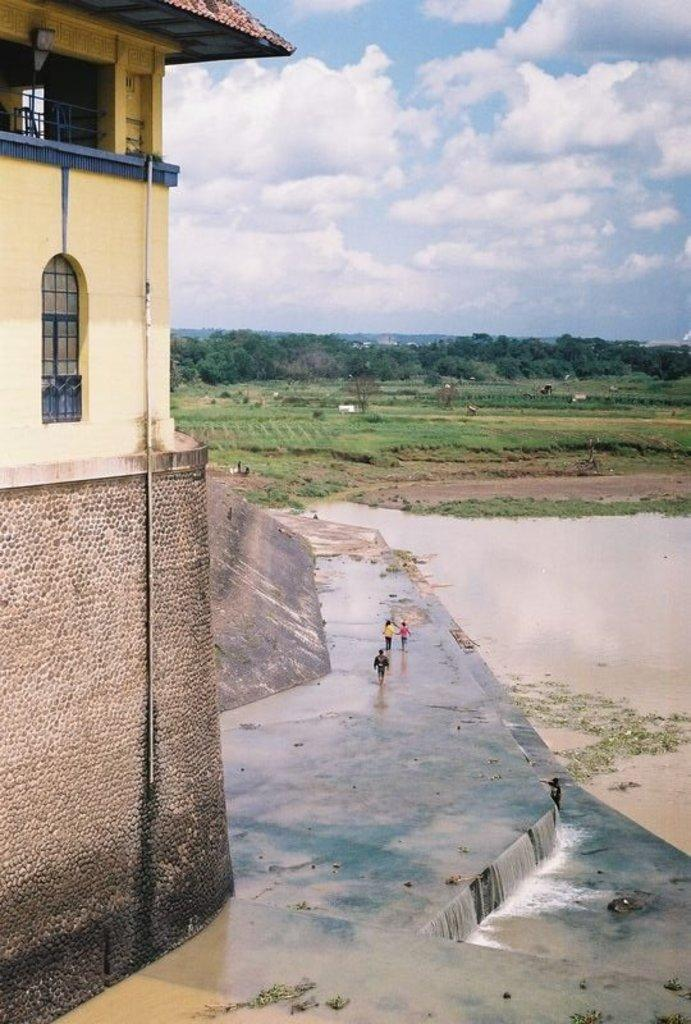What is the primary element visible in the image? There is water in the image. Who or what can be seen in the image? There are people in the image. What type of structure is present in the image? There is a building in the image. What type of vegetation is visible in the image? There is grass and trees in the image. What part of the natural environment is visible in the image? The sky is visible in the image. What can be seen in the sky? Clouds are present in the sky. How many quarters can be seen in the image? There are no quarters present in the image. What type of heart is visible in the image? There is no heart visible in the image. 